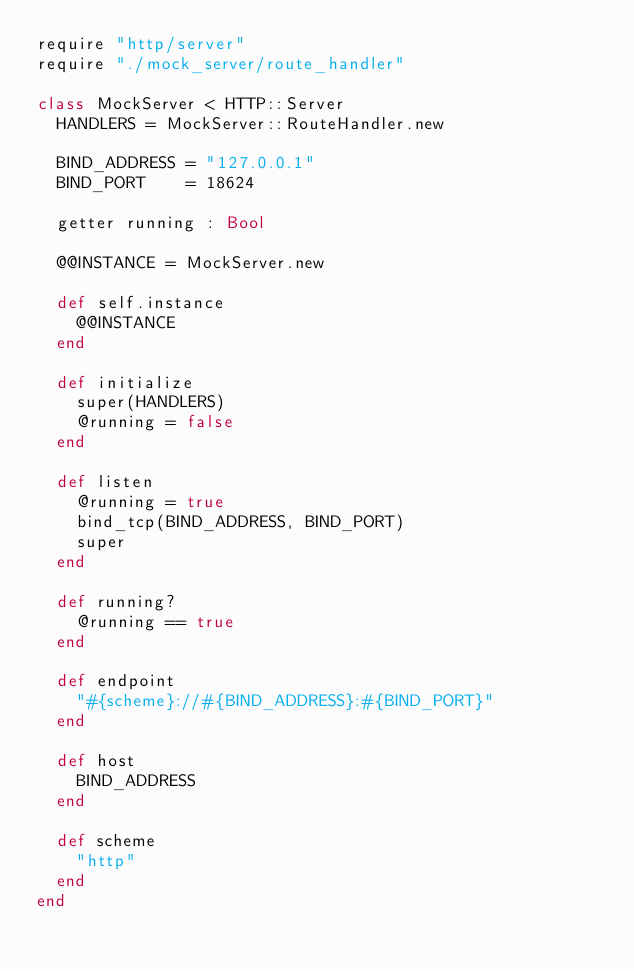Convert code to text. <code><loc_0><loc_0><loc_500><loc_500><_Crystal_>require "http/server"
require "./mock_server/route_handler"

class MockServer < HTTP::Server
  HANDLERS = MockServer::RouteHandler.new

  BIND_ADDRESS = "127.0.0.1"
  BIND_PORT    = 18624

  getter running : Bool

  @@INSTANCE = MockServer.new

  def self.instance
    @@INSTANCE
  end

  def initialize
    super(HANDLERS)
    @running = false
  end

  def listen
    @running = true
    bind_tcp(BIND_ADDRESS, BIND_PORT)
    super
  end

  def running?
    @running == true
  end

  def endpoint
    "#{scheme}://#{BIND_ADDRESS}:#{BIND_PORT}"
  end

  def host
    BIND_ADDRESS
  end

  def scheme
    "http"
  end
end
</code> 